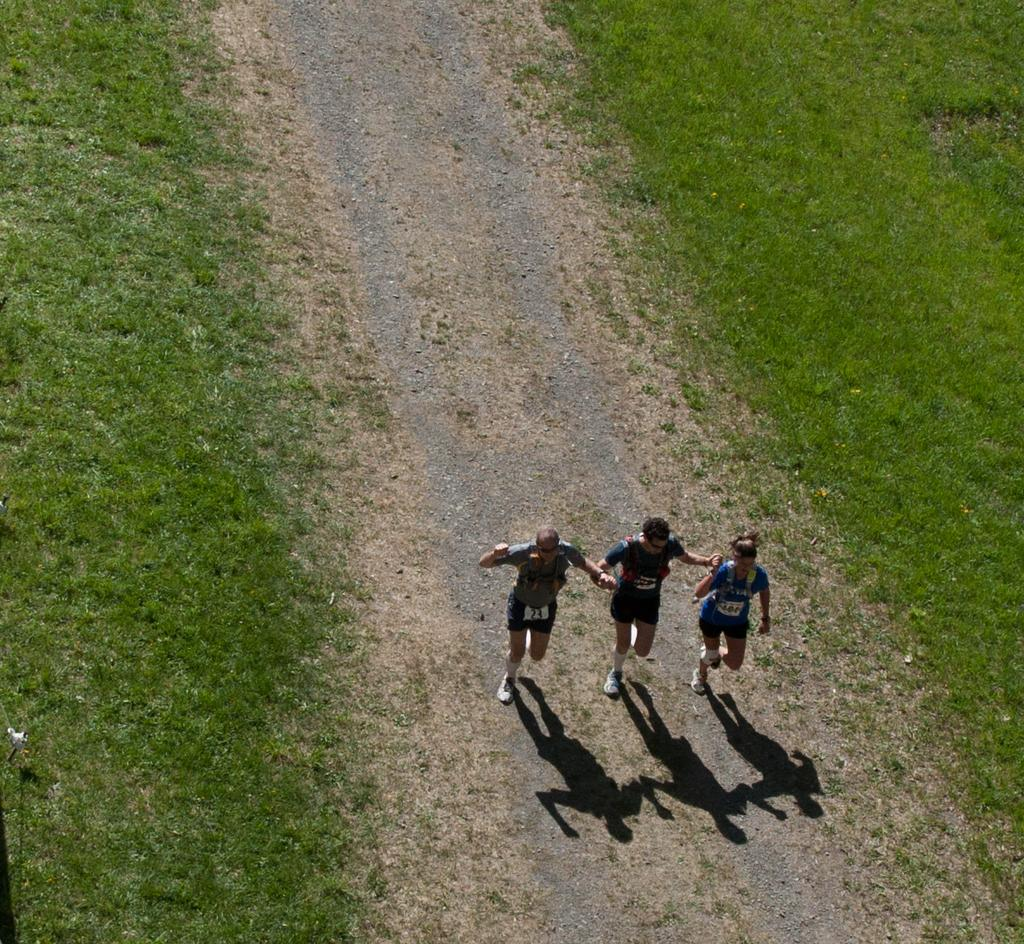How many people are in the image? There are three persons in the image. Where are the persons located in the image? The persons are on the ground. What can be seen in the image besides the persons? The shadow of the persons is visible in the image. What type of vegetation is present in the image? There is grass on both the left and right sides of the image. What type of produce can be seen growing in the image? There is no produce visible in the image; it features three persons on the ground with grass on both sides. 